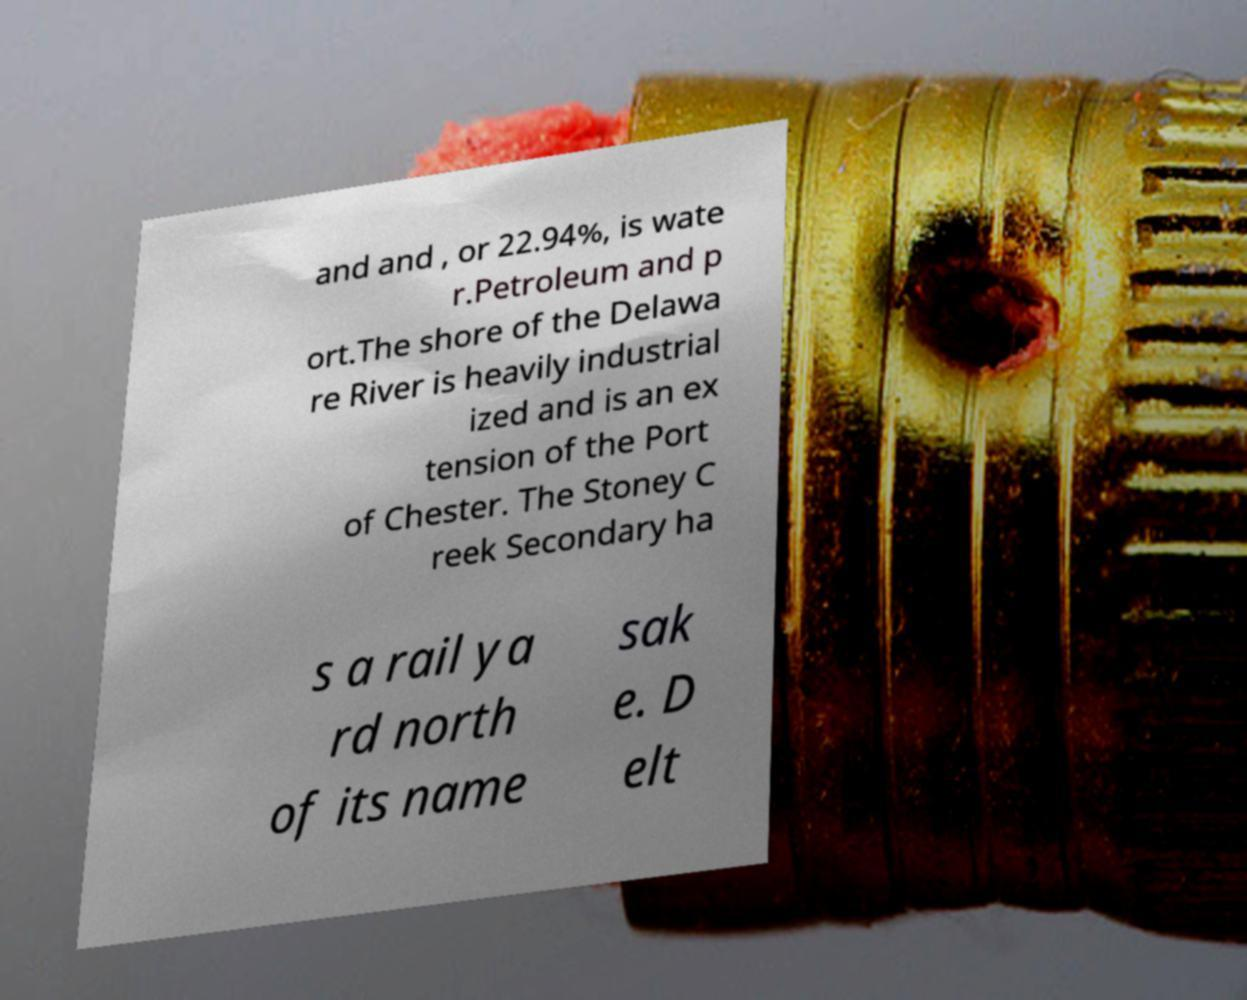Please read and relay the text visible in this image. What does it say? and and , or 22.94%, is wate r.Petroleum and p ort.The shore of the Delawa re River is heavily industrial ized and is an ex tension of the Port of Chester. The Stoney C reek Secondary ha s a rail ya rd north of its name sak e. D elt 